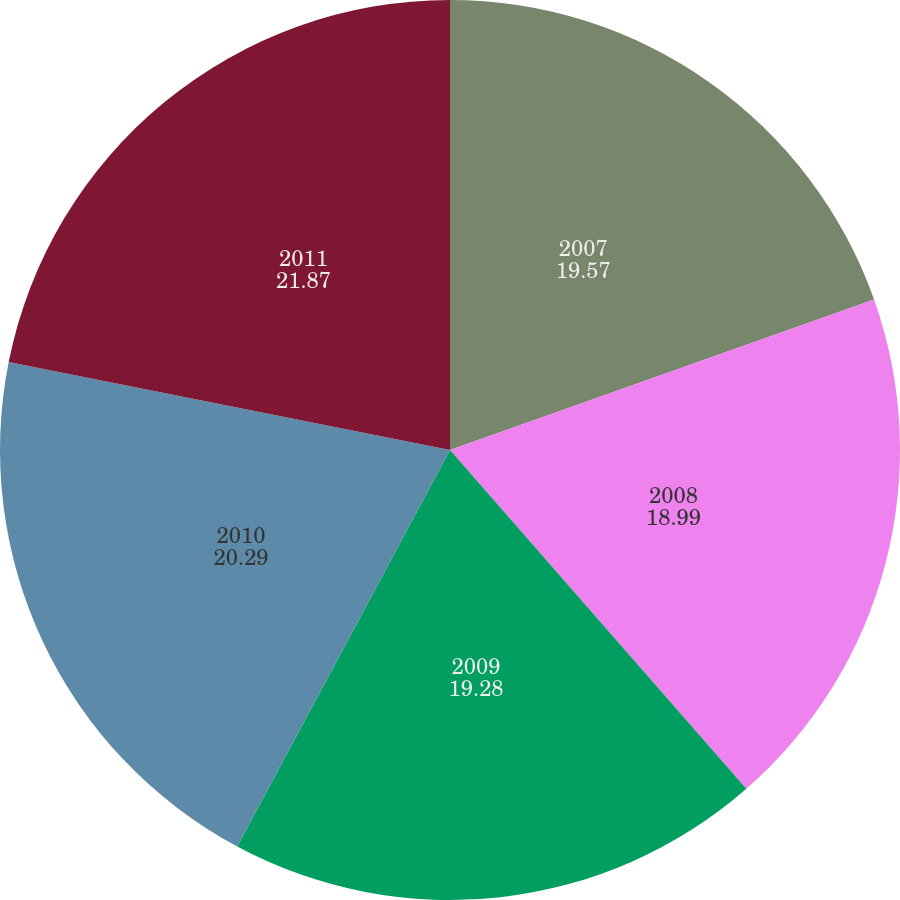Convert chart. <chart><loc_0><loc_0><loc_500><loc_500><pie_chart><fcel>2007<fcel>2008<fcel>2009<fcel>2010<fcel>2011<nl><fcel>19.57%<fcel>18.99%<fcel>19.28%<fcel>20.29%<fcel>21.87%<nl></chart> 